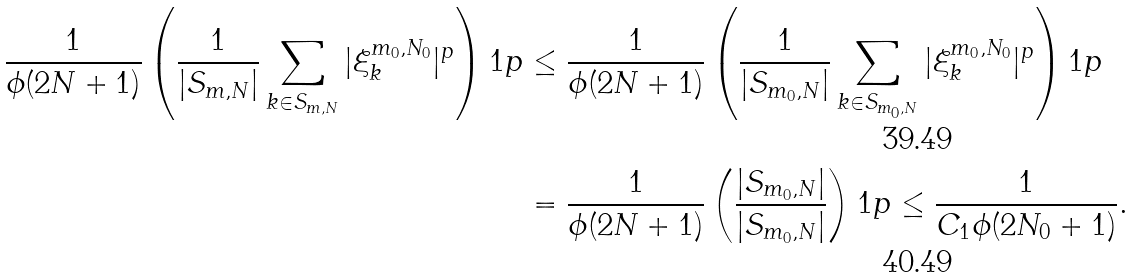<formula> <loc_0><loc_0><loc_500><loc_500>\frac { 1 } { \phi ( 2 N + 1 ) } \left ( \frac { 1 } { | S _ { m , N } | } \sum _ { k \in S _ { m , N } } | \xi ^ { m _ { 0 } , N _ { 0 } } _ { k } | ^ { p } \right ) ^ { } { 1 } p & \leq \frac { 1 } { \phi ( 2 N + 1 ) } \left ( \frac { 1 } { | S _ { m _ { 0 } , N } | } \sum _ { k \in S _ { m _ { 0 } , N } } | \xi ^ { m _ { 0 } , N _ { 0 } } _ { k } | ^ { p } \right ) ^ { } { 1 } p \\ & = \frac { 1 } { \phi ( 2 N + 1 ) } \left ( \frac { | S _ { m _ { 0 } , N } | } { | S _ { m _ { 0 } , N } | } \right ) ^ { } { 1 } p \leq \frac { 1 } { C _ { 1 } \phi ( 2 N _ { 0 } + 1 ) } .</formula> 